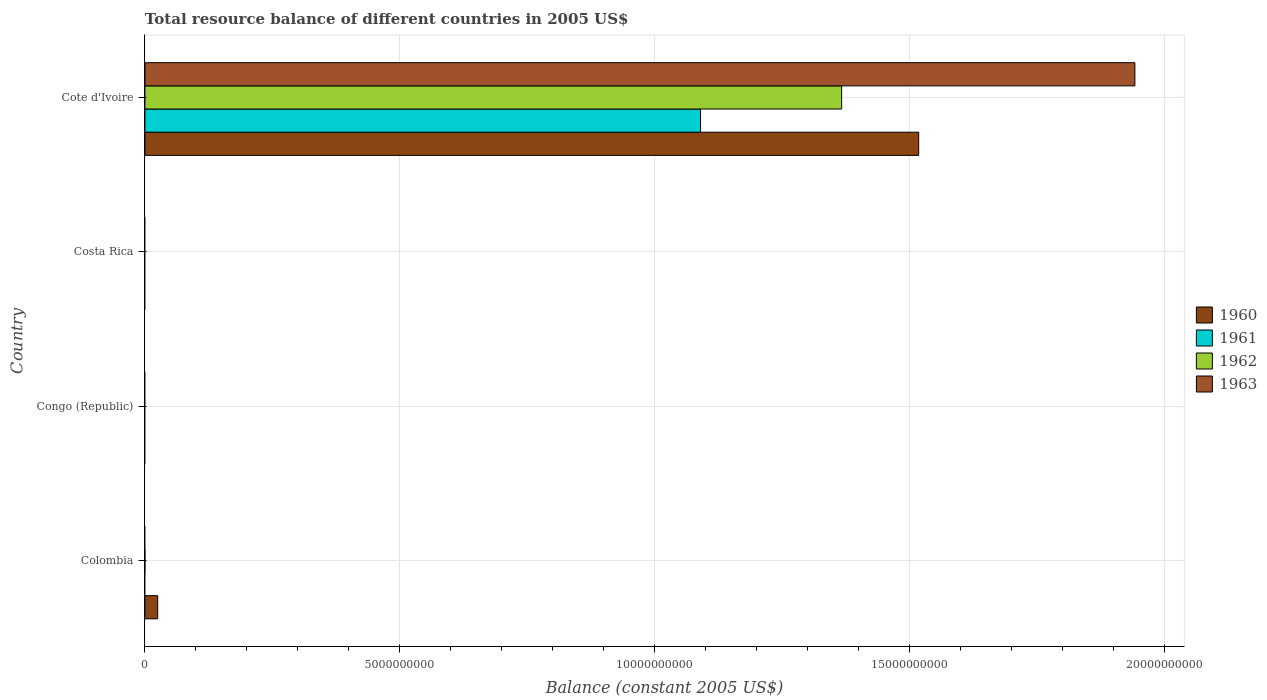Are the number of bars on each tick of the Y-axis equal?
Keep it short and to the point. No. What is the label of the 1st group of bars from the top?
Make the answer very short. Cote d'Ivoire. What is the total resource balance in 1963 in Costa Rica?
Give a very brief answer. 0. Across all countries, what is the maximum total resource balance in 1963?
Give a very brief answer. 1.94e+1. In which country was the total resource balance in 1961 maximum?
Your response must be concise. Cote d'Ivoire. What is the total total resource balance in 1960 in the graph?
Give a very brief answer. 1.54e+1. What is the difference between the total resource balance in 1960 in Colombia and that in Cote d'Ivoire?
Your response must be concise. -1.49e+1. What is the difference between the total resource balance in 1960 in Colombia and the total resource balance in 1962 in Cote d'Ivoire?
Your answer should be compact. -1.34e+1. What is the average total resource balance in 1960 per country?
Your answer should be compact. 3.86e+09. What is the difference between the total resource balance in 1961 and total resource balance in 1963 in Cote d'Ivoire?
Give a very brief answer. -8.52e+09. In how many countries, is the total resource balance in 1960 greater than 8000000000 US$?
Your answer should be compact. 1. What is the difference between the highest and the lowest total resource balance in 1963?
Ensure brevity in your answer.  1.94e+1. Is it the case that in every country, the sum of the total resource balance in 1962 and total resource balance in 1961 is greater than the total resource balance in 1963?
Provide a short and direct response. No. Are all the bars in the graph horizontal?
Provide a short and direct response. Yes. How many countries are there in the graph?
Ensure brevity in your answer.  4. Does the graph contain grids?
Offer a terse response. Yes. What is the title of the graph?
Your answer should be compact. Total resource balance of different countries in 2005 US$. What is the label or title of the X-axis?
Ensure brevity in your answer.  Balance (constant 2005 US$). What is the label or title of the Y-axis?
Offer a terse response. Country. What is the Balance (constant 2005 US$) in 1960 in Colombia?
Make the answer very short. 2.51e+08. What is the Balance (constant 2005 US$) of 1961 in Colombia?
Ensure brevity in your answer.  0. What is the Balance (constant 2005 US$) in 1962 in Colombia?
Provide a short and direct response. 0. What is the Balance (constant 2005 US$) in 1960 in Congo (Republic)?
Give a very brief answer. 0. What is the Balance (constant 2005 US$) in 1961 in Congo (Republic)?
Your answer should be very brief. 0. What is the Balance (constant 2005 US$) in 1963 in Congo (Republic)?
Your answer should be very brief. 0. What is the Balance (constant 2005 US$) of 1961 in Costa Rica?
Provide a short and direct response. 0. What is the Balance (constant 2005 US$) in 1962 in Costa Rica?
Give a very brief answer. 0. What is the Balance (constant 2005 US$) in 1963 in Costa Rica?
Your response must be concise. 0. What is the Balance (constant 2005 US$) in 1960 in Cote d'Ivoire?
Your answer should be compact. 1.52e+1. What is the Balance (constant 2005 US$) in 1961 in Cote d'Ivoire?
Offer a terse response. 1.09e+1. What is the Balance (constant 2005 US$) of 1962 in Cote d'Ivoire?
Your response must be concise. 1.37e+1. What is the Balance (constant 2005 US$) in 1963 in Cote d'Ivoire?
Ensure brevity in your answer.  1.94e+1. Across all countries, what is the maximum Balance (constant 2005 US$) of 1960?
Your response must be concise. 1.52e+1. Across all countries, what is the maximum Balance (constant 2005 US$) in 1961?
Provide a short and direct response. 1.09e+1. Across all countries, what is the maximum Balance (constant 2005 US$) of 1962?
Make the answer very short. 1.37e+1. Across all countries, what is the maximum Balance (constant 2005 US$) in 1963?
Provide a short and direct response. 1.94e+1. Across all countries, what is the minimum Balance (constant 2005 US$) in 1960?
Make the answer very short. 0. Across all countries, what is the minimum Balance (constant 2005 US$) in 1961?
Provide a succinct answer. 0. Across all countries, what is the minimum Balance (constant 2005 US$) in 1963?
Provide a short and direct response. 0. What is the total Balance (constant 2005 US$) in 1960 in the graph?
Give a very brief answer. 1.54e+1. What is the total Balance (constant 2005 US$) in 1961 in the graph?
Your response must be concise. 1.09e+1. What is the total Balance (constant 2005 US$) of 1962 in the graph?
Offer a terse response. 1.37e+1. What is the total Balance (constant 2005 US$) in 1963 in the graph?
Keep it short and to the point. 1.94e+1. What is the difference between the Balance (constant 2005 US$) of 1960 in Colombia and that in Cote d'Ivoire?
Make the answer very short. -1.49e+1. What is the difference between the Balance (constant 2005 US$) of 1960 in Colombia and the Balance (constant 2005 US$) of 1961 in Cote d'Ivoire?
Ensure brevity in your answer.  -1.07e+1. What is the difference between the Balance (constant 2005 US$) in 1960 in Colombia and the Balance (constant 2005 US$) in 1962 in Cote d'Ivoire?
Keep it short and to the point. -1.34e+1. What is the difference between the Balance (constant 2005 US$) of 1960 in Colombia and the Balance (constant 2005 US$) of 1963 in Cote d'Ivoire?
Your answer should be compact. -1.92e+1. What is the average Balance (constant 2005 US$) in 1960 per country?
Keep it short and to the point. 3.86e+09. What is the average Balance (constant 2005 US$) of 1961 per country?
Your answer should be very brief. 2.73e+09. What is the average Balance (constant 2005 US$) in 1962 per country?
Your answer should be very brief. 3.42e+09. What is the average Balance (constant 2005 US$) of 1963 per country?
Offer a very short reply. 4.86e+09. What is the difference between the Balance (constant 2005 US$) in 1960 and Balance (constant 2005 US$) in 1961 in Cote d'Ivoire?
Ensure brevity in your answer.  4.28e+09. What is the difference between the Balance (constant 2005 US$) in 1960 and Balance (constant 2005 US$) in 1962 in Cote d'Ivoire?
Keep it short and to the point. 1.51e+09. What is the difference between the Balance (constant 2005 US$) in 1960 and Balance (constant 2005 US$) in 1963 in Cote d'Ivoire?
Your response must be concise. -4.24e+09. What is the difference between the Balance (constant 2005 US$) of 1961 and Balance (constant 2005 US$) of 1962 in Cote d'Ivoire?
Your answer should be very brief. -2.77e+09. What is the difference between the Balance (constant 2005 US$) in 1961 and Balance (constant 2005 US$) in 1963 in Cote d'Ivoire?
Make the answer very short. -8.52e+09. What is the difference between the Balance (constant 2005 US$) in 1962 and Balance (constant 2005 US$) in 1963 in Cote d'Ivoire?
Give a very brief answer. -5.75e+09. What is the ratio of the Balance (constant 2005 US$) of 1960 in Colombia to that in Cote d'Ivoire?
Your response must be concise. 0.02. What is the difference between the highest and the lowest Balance (constant 2005 US$) in 1960?
Keep it short and to the point. 1.52e+1. What is the difference between the highest and the lowest Balance (constant 2005 US$) in 1961?
Your answer should be compact. 1.09e+1. What is the difference between the highest and the lowest Balance (constant 2005 US$) of 1962?
Offer a very short reply. 1.37e+1. What is the difference between the highest and the lowest Balance (constant 2005 US$) of 1963?
Give a very brief answer. 1.94e+1. 